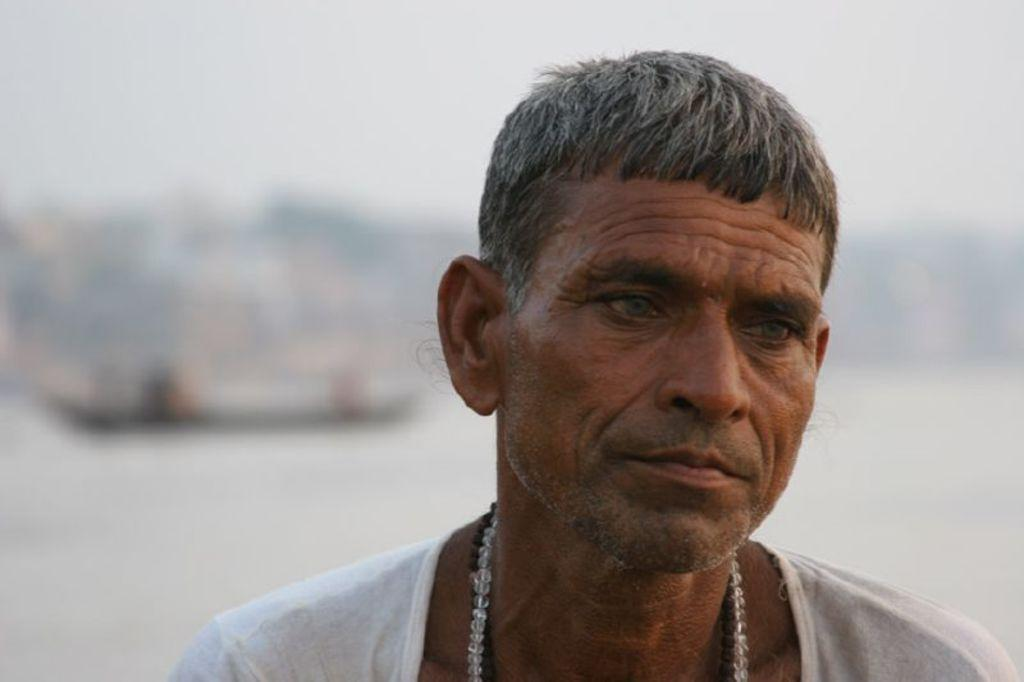What is the main subject of the image? There is a person's face in the image. Can you describe the background of the image? The background of the image is blurred. What type of chair is visible in the image? There is no chair present in the image; it only features a person's face and a blurred background. What scientific discoveries can be observed in the image? There are no scientific discoveries depicted in the image; it only features a person's face and a blurred background. 